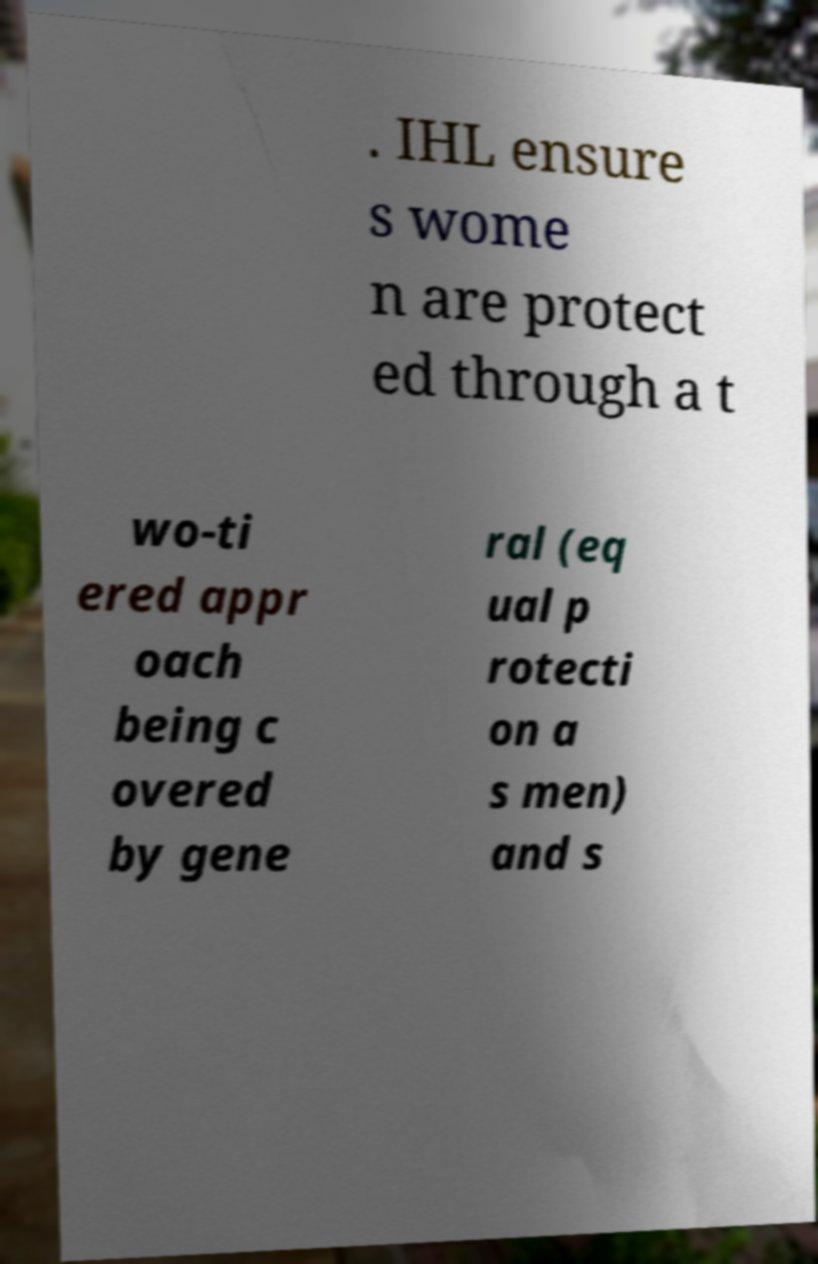For documentation purposes, I need the text within this image transcribed. Could you provide that? . IHL ensure s wome n are protect ed through a t wo-ti ered appr oach being c overed by gene ral (eq ual p rotecti on a s men) and s 